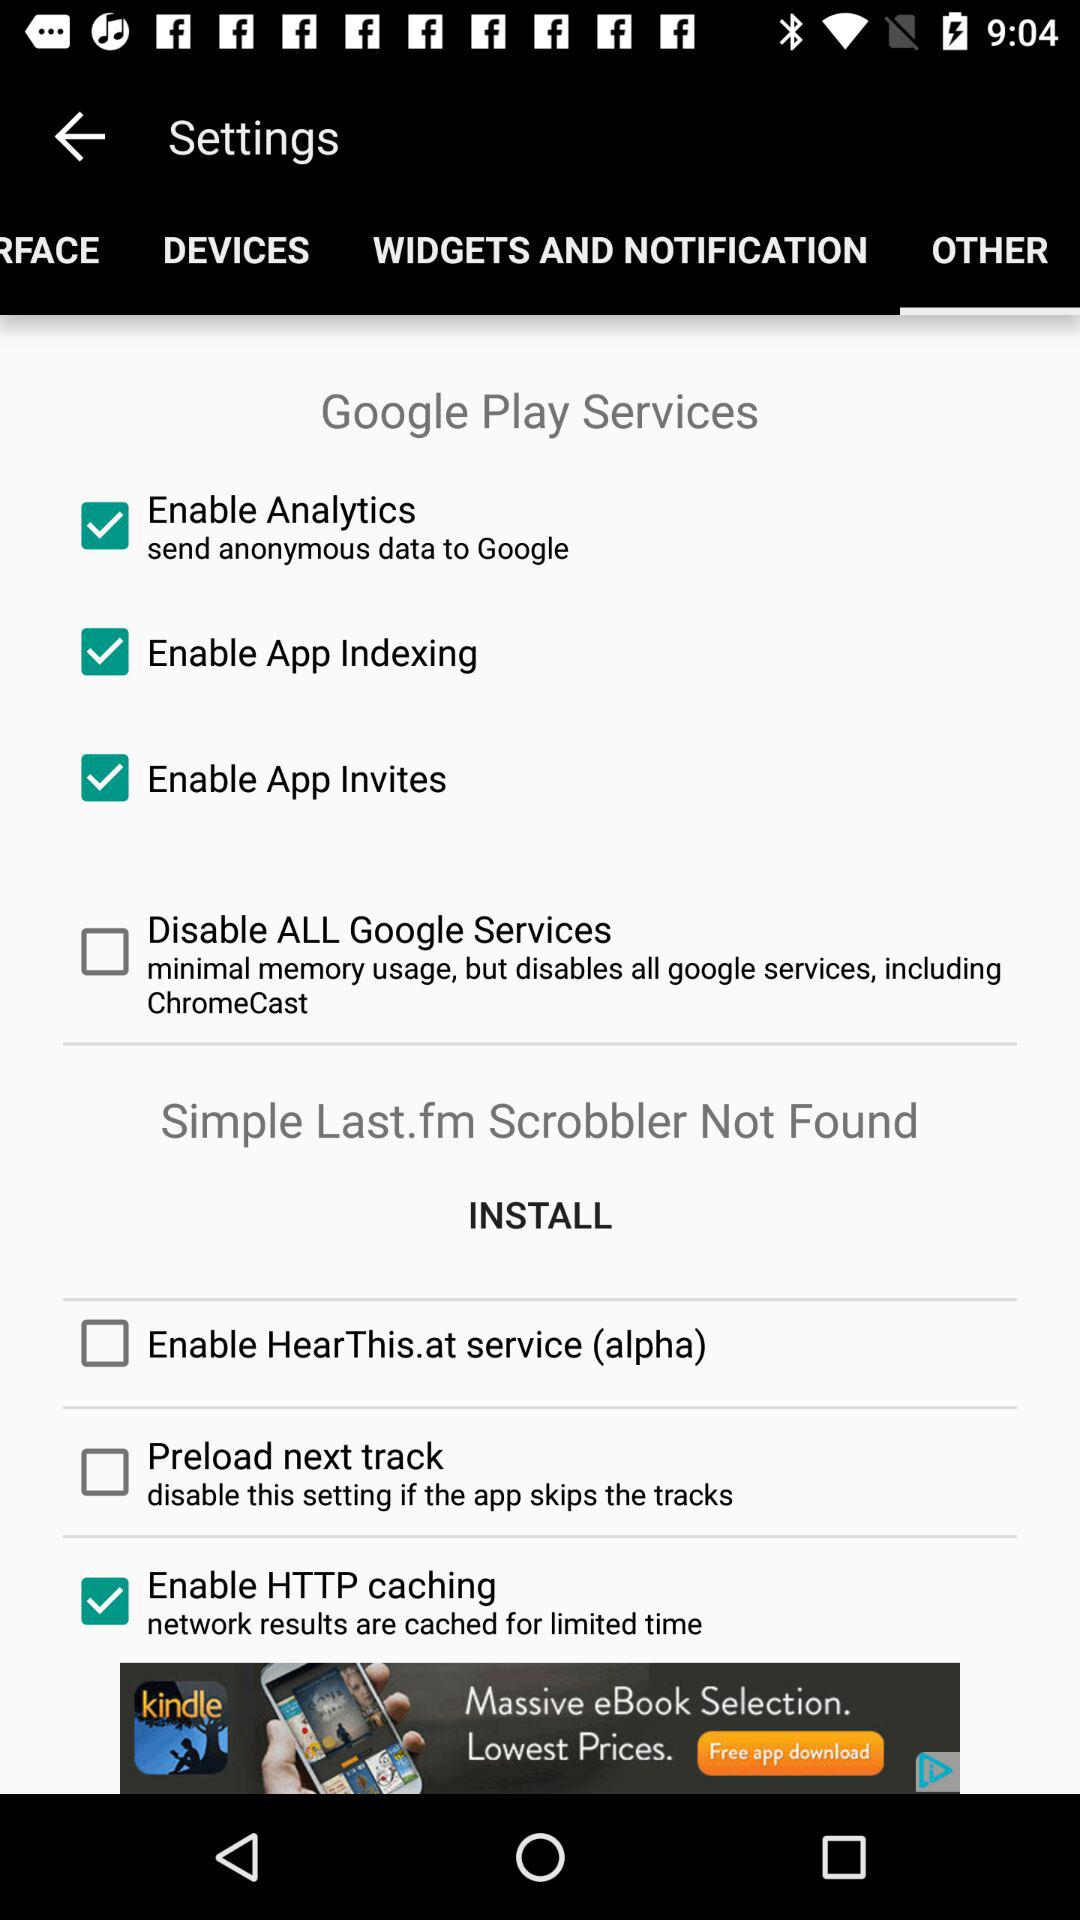What is the status of "Enable Analytics"? The status is "on". 